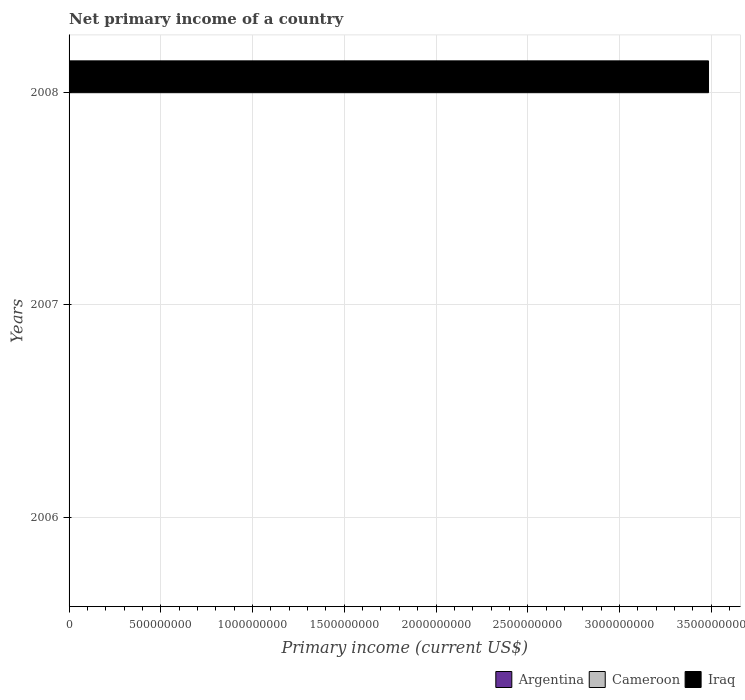How many different coloured bars are there?
Offer a very short reply. 1. Are the number of bars per tick equal to the number of legend labels?
Your response must be concise. No. How many bars are there on the 3rd tick from the top?
Your answer should be very brief. 0. What is the label of the 2nd group of bars from the top?
Your answer should be compact. 2007. In how many cases, is the number of bars for a given year not equal to the number of legend labels?
Offer a terse response. 3. What is the primary income in Argentina in 2008?
Provide a short and direct response. 0. Across all years, what is the maximum primary income in Iraq?
Ensure brevity in your answer.  3.49e+09. In which year was the primary income in Iraq maximum?
Provide a succinct answer. 2008. What is the average primary income in Iraq per year?
Your response must be concise. 1.16e+09. What is the difference between the highest and the lowest primary income in Iraq?
Make the answer very short. 3.49e+09. Are the values on the major ticks of X-axis written in scientific E-notation?
Your response must be concise. No. Does the graph contain any zero values?
Your answer should be compact. Yes. How are the legend labels stacked?
Provide a succinct answer. Horizontal. What is the title of the graph?
Provide a succinct answer. Net primary income of a country. What is the label or title of the X-axis?
Ensure brevity in your answer.  Primary income (current US$). What is the label or title of the Y-axis?
Your answer should be compact. Years. What is the Primary income (current US$) of Argentina in 2006?
Your response must be concise. 0. What is the Primary income (current US$) of Iraq in 2007?
Make the answer very short. 0. What is the Primary income (current US$) of Iraq in 2008?
Provide a succinct answer. 3.49e+09. Across all years, what is the maximum Primary income (current US$) of Iraq?
Ensure brevity in your answer.  3.49e+09. Across all years, what is the minimum Primary income (current US$) of Iraq?
Give a very brief answer. 0. What is the total Primary income (current US$) of Argentina in the graph?
Offer a terse response. 0. What is the total Primary income (current US$) of Cameroon in the graph?
Provide a short and direct response. 0. What is the total Primary income (current US$) of Iraq in the graph?
Your answer should be compact. 3.49e+09. What is the average Primary income (current US$) of Argentina per year?
Your answer should be compact. 0. What is the average Primary income (current US$) of Iraq per year?
Offer a terse response. 1.16e+09. What is the difference between the highest and the lowest Primary income (current US$) in Iraq?
Keep it short and to the point. 3.49e+09. 